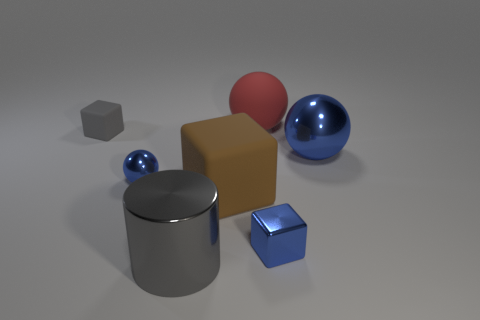Add 2 tiny green matte objects. How many objects exist? 9 Subtract all blue spheres. How many spheres are left? 1 Subtract all tiny metallic cubes. Subtract all large brown matte things. How many objects are left? 5 Add 4 small blue shiny things. How many small blue shiny things are left? 6 Add 5 small cyan cylinders. How many small cyan cylinders exist? 5 Subtract all blue balls. How many balls are left? 1 Subtract 0 blue cylinders. How many objects are left? 7 Subtract all blocks. How many objects are left? 4 Subtract 1 cylinders. How many cylinders are left? 0 Subtract all purple blocks. Subtract all gray spheres. How many blocks are left? 3 